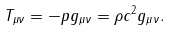<formula> <loc_0><loc_0><loc_500><loc_500>T _ { \mu \nu } = - p g _ { \mu \nu } = \rho c ^ { 2 } g _ { \mu \nu } .</formula> 